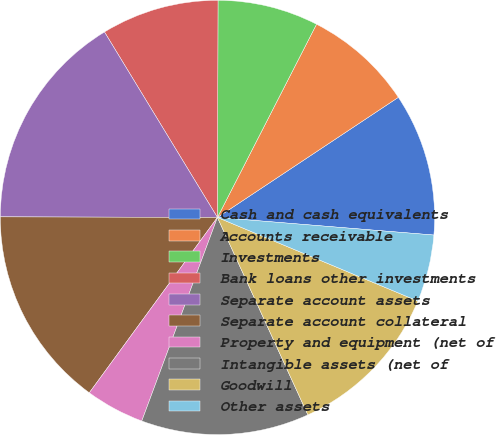<chart> <loc_0><loc_0><loc_500><loc_500><pie_chart><fcel>Cash and cash equivalents<fcel>Accounts receivable<fcel>Investments<fcel>Bank loans other investments<fcel>Separate account assets<fcel>Separate account collateral<fcel>Property and equipment (net of<fcel>Intangible assets (net of<fcel>Goodwill<fcel>Other assets<nl><fcel>10.62%<fcel>8.13%<fcel>7.5%<fcel>8.75%<fcel>16.25%<fcel>15.0%<fcel>4.38%<fcel>12.5%<fcel>11.87%<fcel>5.0%<nl></chart> 